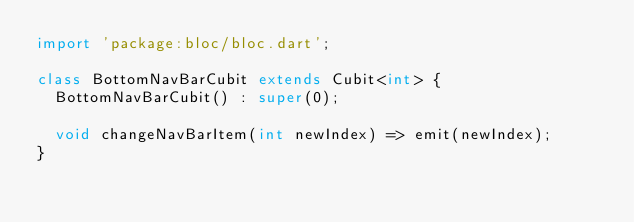<code> <loc_0><loc_0><loc_500><loc_500><_Dart_>import 'package:bloc/bloc.dart';

class BottomNavBarCubit extends Cubit<int> {
  BottomNavBarCubit() : super(0);

  void changeNavBarItem(int newIndex) => emit(newIndex);
}
</code> 